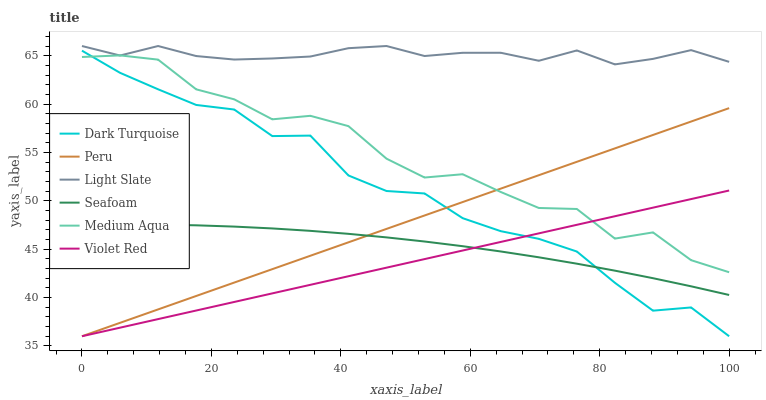Does Violet Red have the minimum area under the curve?
Answer yes or no. Yes. Does Light Slate have the maximum area under the curve?
Answer yes or no. Yes. Does Dark Turquoise have the minimum area under the curve?
Answer yes or no. No. Does Dark Turquoise have the maximum area under the curve?
Answer yes or no. No. Is Violet Red the smoothest?
Answer yes or no. Yes. Is Medium Aqua the roughest?
Answer yes or no. Yes. Is Light Slate the smoothest?
Answer yes or no. No. Is Light Slate the roughest?
Answer yes or no. No. Does Violet Red have the lowest value?
Answer yes or no. Yes. Does Light Slate have the lowest value?
Answer yes or no. No. Does Light Slate have the highest value?
Answer yes or no. Yes. Does Dark Turquoise have the highest value?
Answer yes or no. No. Is Dark Turquoise less than Light Slate?
Answer yes or no. Yes. Is Light Slate greater than Violet Red?
Answer yes or no. Yes. Does Medium Aqua intersect Violet Red?
Answer yes or no. Yes. Is Medium Aqua less than Violet Red?
Answer yes or no. No. Is Medium Aqua greater than Violet Red?
Answer yes or no. No. Does Dark Turquoise intersect Light Slate?
Answer yes or no. No. 